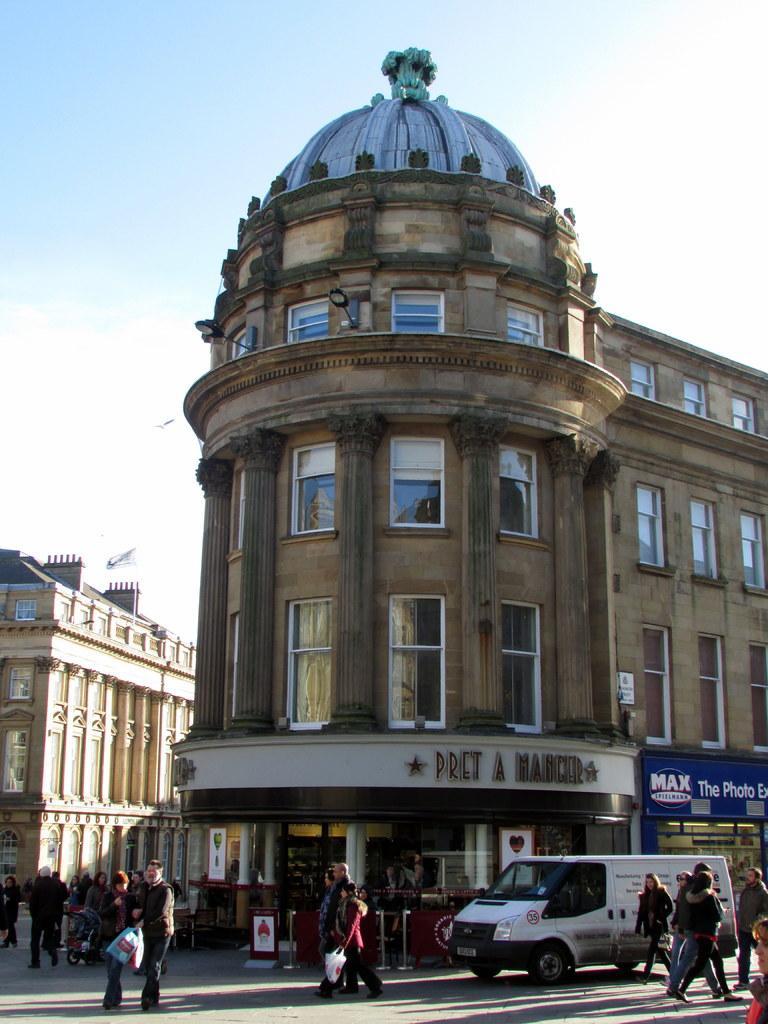Describe this image in one or two sentences. In this image we can see buildings, in front of the building there is a vehicle and a few people walking on the road, there is a board attached to the building and sky in the background. 